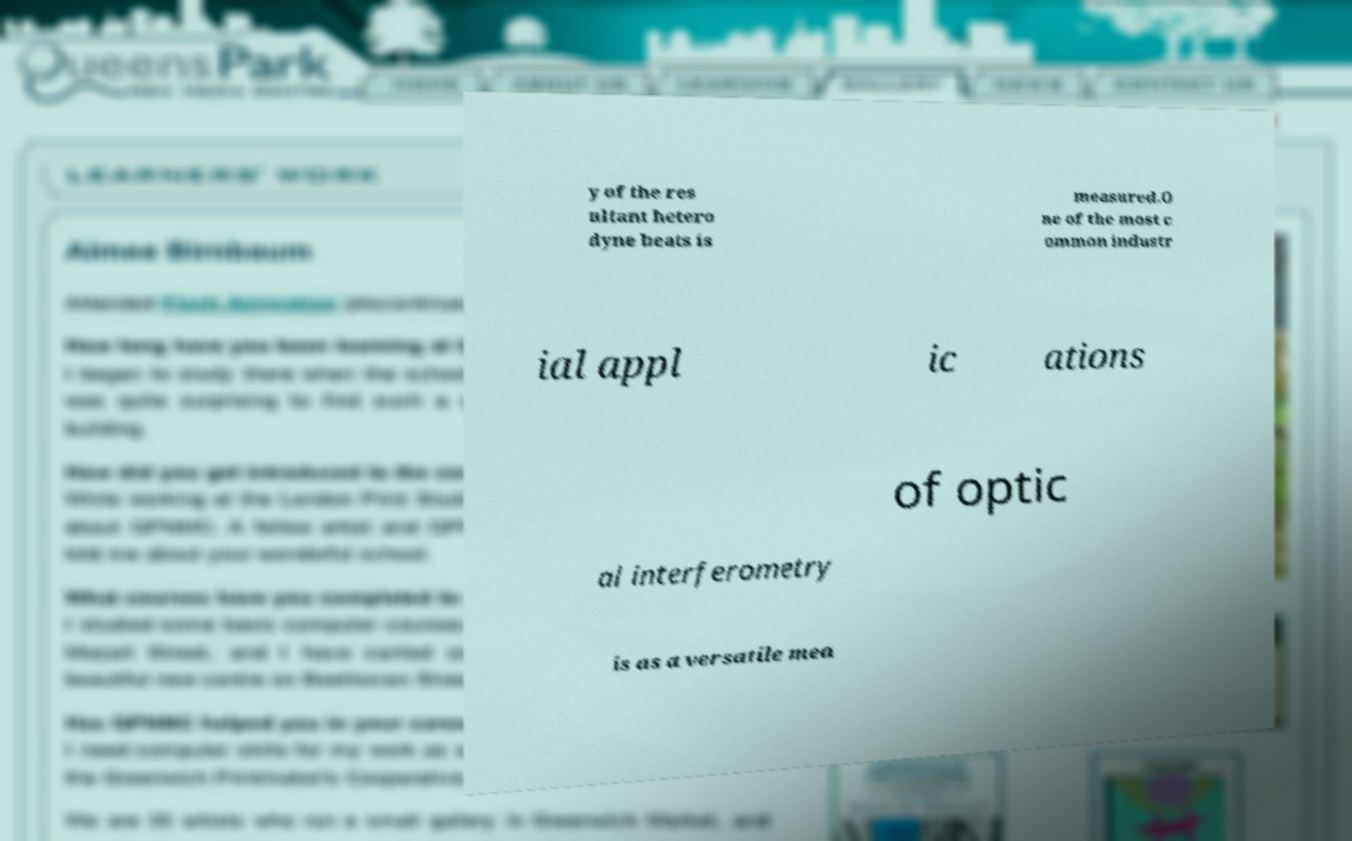What messages or text are displayed in this image? I need them in a readable, typed format. y of the res ultant hetero dyne beats is measured.O ne of the most c ommon industr ial appl ic ations of optic al interferometry is as a versatile mea 